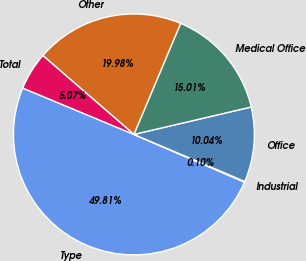Convert chart. <chart><loc_0><loc_0><loc_500><loc_500><pie_chart><fcel>Type<fcel>Industrial<fcel>Office<fcel>Medical Office<fcel>Other<fcel>Total<nl><fcel>49.81%<fcel>0.1%<fcel>10.04%<fcel>15.01%<fcel>19.98%<fcel>5.07%<nl></chart> 